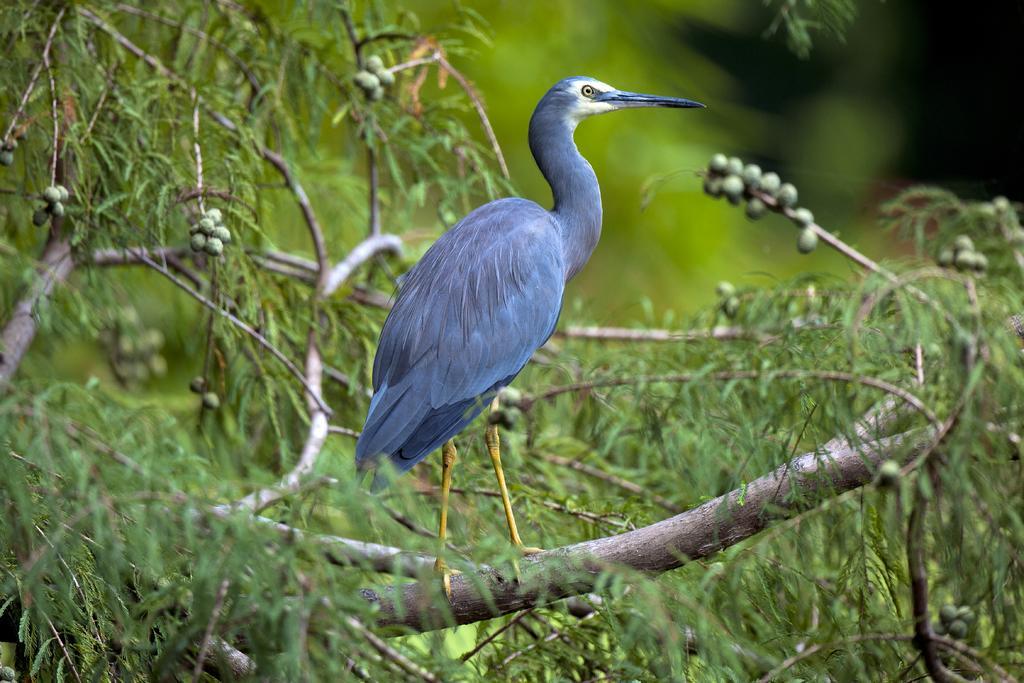Describe this image in one or two sentences. In this image, we can see a bird on the tree. In the background, image is blurred. 